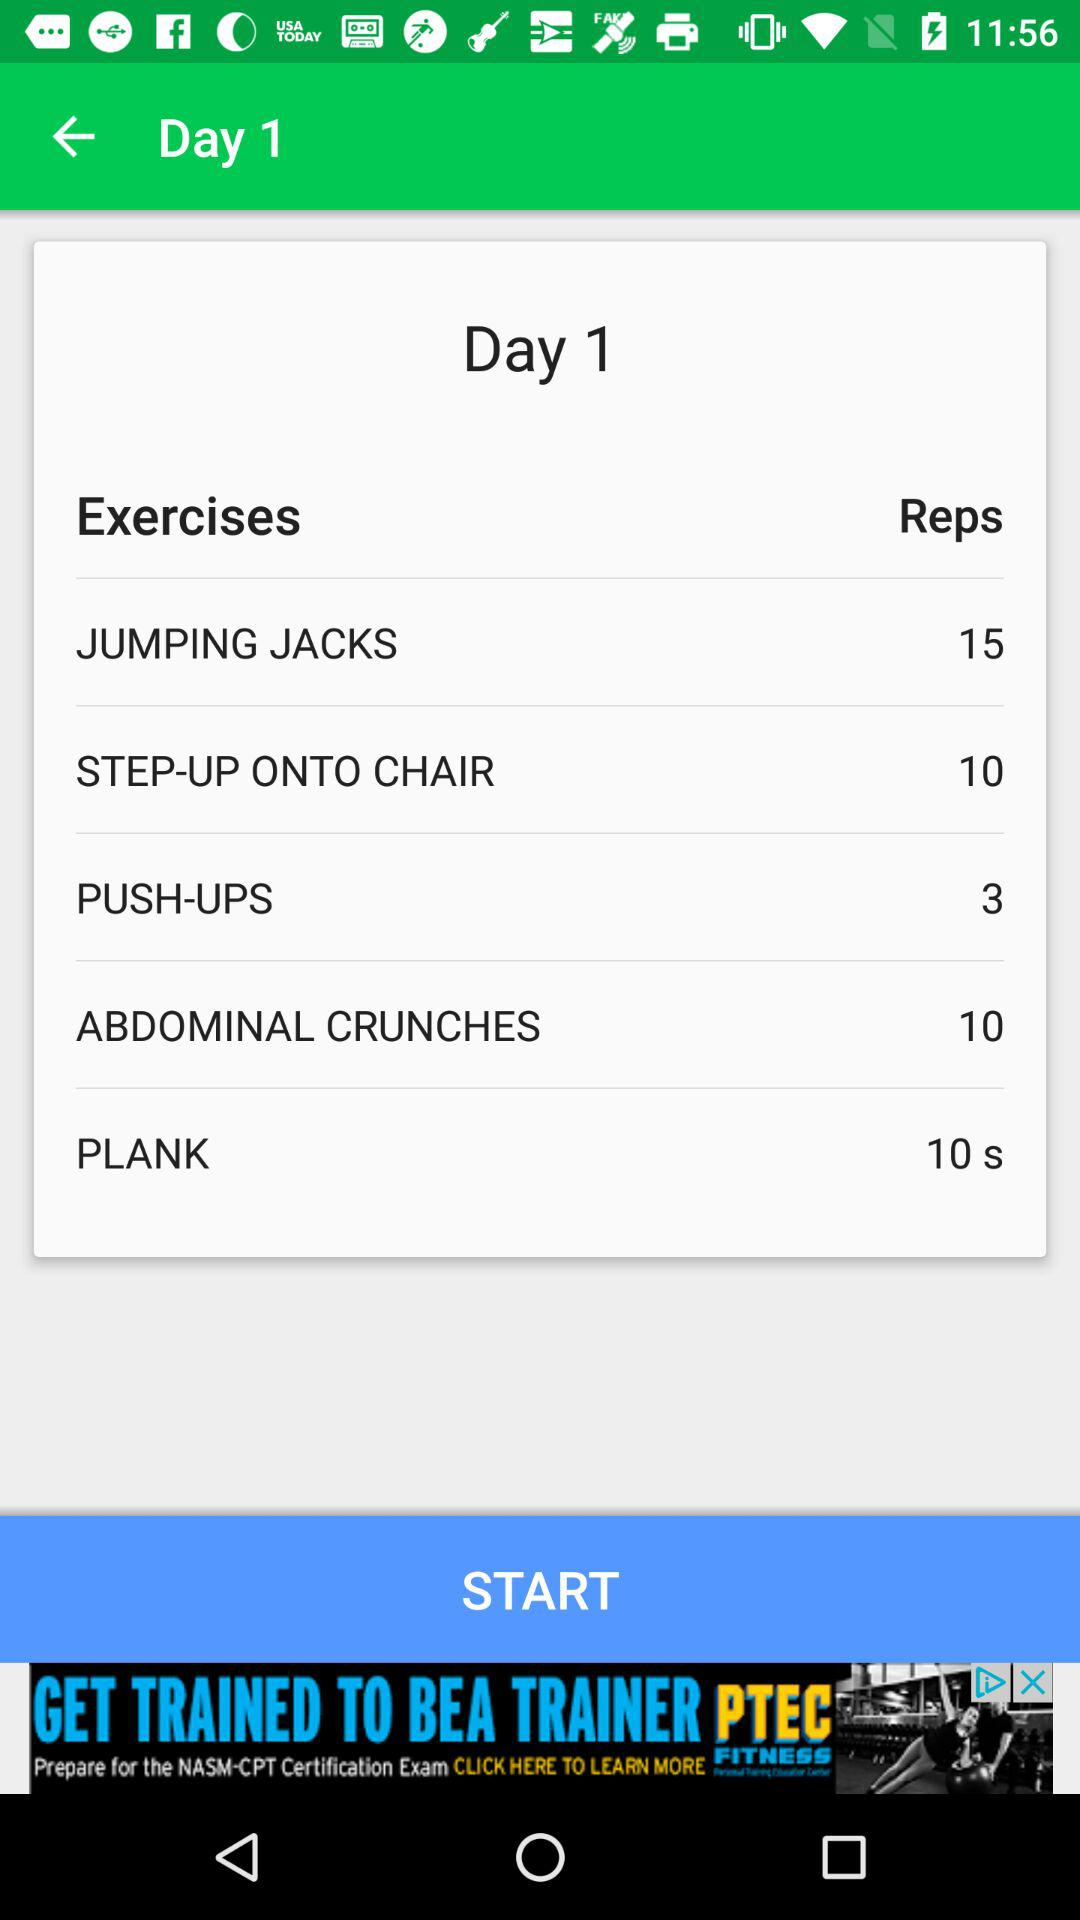How many more repetitions of abdominal crunches are there than push-ups?
Answer the question using a single word or phrase. 7 